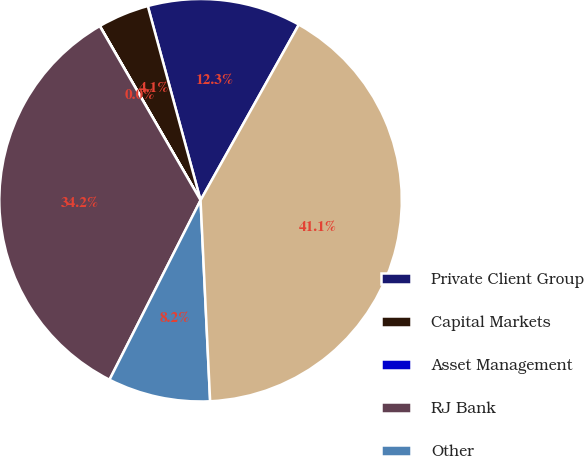<chart> <loc_0><loc_0><loc_500><loc_500><pie_chart><fcel>Private Client Group<fcel>Capital Markets<fcel>Asset Management<fcel>RJ Bank<fcel>Other<fcel>Net interest income<nl><fcel>12.34%<fcel>4.12%<fcel>0.01%<fcel>34.17%<fcel>8.23%<fcel>41.12%<nl></chart> 